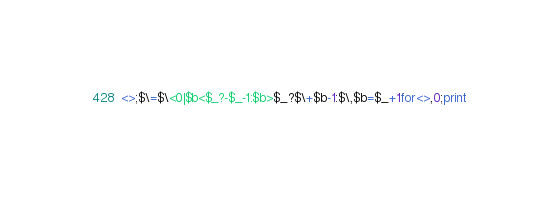<code> <loc_0><loc_0><loc_500><loc_500><_Perl_><>;$\=$\<0|$b<$_?-$_-1:$b>$_?$\+$b-1:$\,$b=$_+1for<>,0;print</code> 